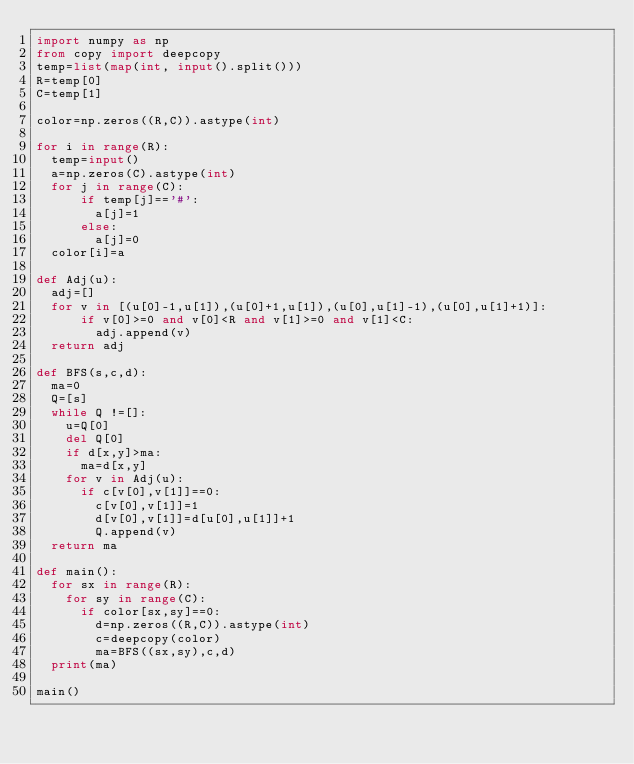<code> <loc_0><loc_0><loc_500><loc_500><_Python_>import numpy as np
from copy import deepcopy
temp=list(map(int, input().split()))
R=temp[0]
C=temp[1]

color=np.zeros((R,C)).astype(int)

for i in range(R):
  temp=input()
  a=np.zeros(C).astype(int)
  for j in range(C):
      if temp[j]=='#':
        a[j]=1
      else:
        a[j]=0
  color[i]=a
  
def Adj(u):
  adj=[]
  for v in [(u[0]-1,u[1]),(u[0]+1,u[1]),(u[0],u[1]-1),(u[0],u[1]+1)]:
      if v[0]>=0 and v[0]<R and v[1]>=0 and v[1]<C:
        adj.append(v)
  return adj  

def BFS(s,c,d):
  ma=0
  Q=[s]
  while Q !=[]:
    u=Q[0]
    del Q[0]
    if d[x,y]>ma:
      ma=d[x,y]
    for v in Adj(u):  
      if c[v[0],v[1]]==0:
        c[v[0],v[1]]=1
        d[v[0],v[1]]=d[u[0],u[1]]+1
        Q.append(v)
  return ma
        
def main():
  for sx in range(R):
    for sy in range(C):
      if color[sx,sy]==0:
        d=np.zeros((R,C)).astype(int)
        c=deepcopy(color)
        ma=BFS((sx,sy),c,d)
  print(ma)
  
main()
</code> 